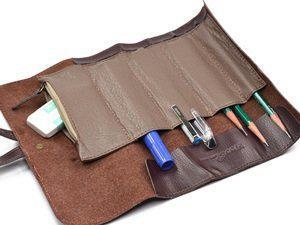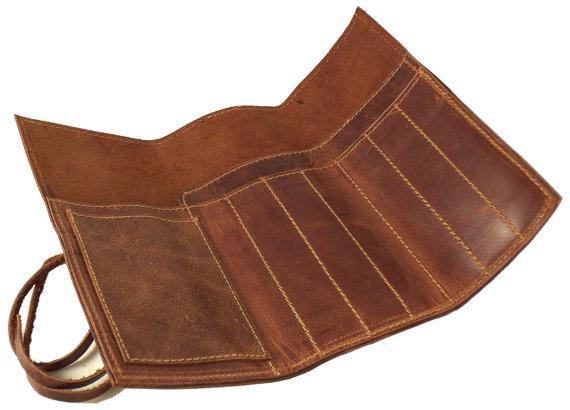The first image is the image on the left, the second image is the image on the right. Considering the images on both sides, is "An image shows one leather pencil case, displayed open with writing implements tucked inside." valid? Answer yes or no. Yes. The first image is the image on the left, the second image is the image on the right. Analyze the images presented: Is the assertion "In one image, a leather pencil case is displayed closed in at least four colors, while the other image displays how a different brown case looks when opened." valid? Answer yes or no. No. 